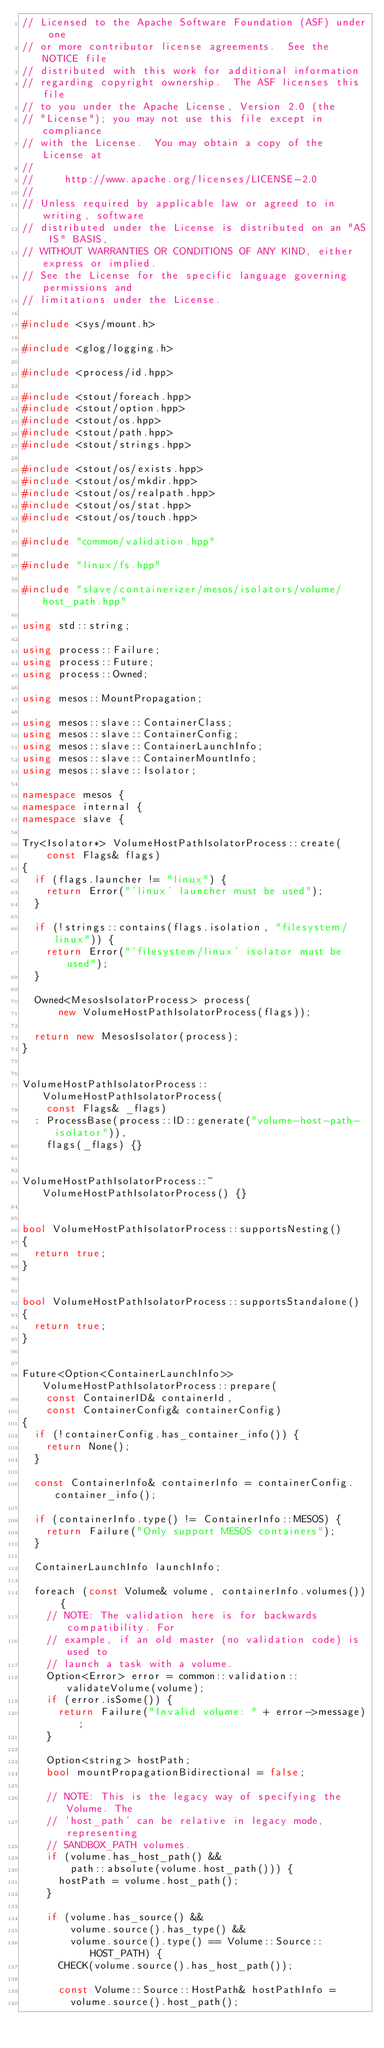<code> <loc_0><loc_0><loc_500><loc_500><_C++_>// Licensed to the Apache Software Foundation (ASF) under one
// or more contributor license agreements.  See the NOTICE file
// distributed with this work for additional information
// regarding copyright ownership.  The ASF licenses this file
// to you under the Apache License, Version 2.0 (the
// "License"); you may not use this file except in compliance
// with the License.  You may obtain a copy of the License at
//
//     http://www.apache.org/licenses/LICENSE-2.0
//
// Unless required by applicable law or agreed to in writing, software
// distributed under the License is distributed on an "AS IS" BASIS,
// WITHOUT WARRANTIES OR CONDITIONS OF ANY KIND, either express or implied.
// See the License for the specific language governing permissions and
// limitations under the License.

#include <sys/mount.h>

#include <glog/logging.h>

#include <process/id.hpp>

#include <stout/foreach.hpp>
#include <stout/option.hpp>
#include <stout/os.hpp>
#include <stout/path.hpp>
#include <stout/strings.hpp>

#include <stout/os/exists.hpp>
#include <stout/os/mkdir.hpp>
#include <stout/os/realpath.hpp>
#include <stout/os/stat.hpp>
#include <stout/os/touch.hpp>

#include "common/validation.hpp"

#include "linux/fs.hpp"

#include "slave/containerizer/mesos/isolators/volume/host_path.hpp"

using std::string;

using process::Failure;
using process::Future;
using process::Owned;

using mesos::MountPropagation;

using mesos::slave::ContainerClass;
using mesos::slave::ContainerConfig;
using mesos::slave::ContainerLaunchInfo;
using mesos::slave::ContainerMountInfo;
using mesos::slave::Isolator;

namespace mesos {
namespace internal {
namespace slave {

Try<Isolator*> VolumeHostPathIsolatorProcess::create(
    const Flags& flags)
{
  if (flags.launcher != "linux") {
    return Error("'linux' launcher must be used");
  }

  if (!strings::contains(flags.isolation, "filesystem/linux")) {
    return Error("'filesystem/linux' isolator must be used");
  }

  Owned<MesosIsolatorProcess> process(
      new VolumeHostPathIsolatorProcess(flags));

  return new MesosIsolator(process);
}


VolumeHostPathIsolatorProcess::VolumeHostPathIsolatorProcess(
    const Flags& _flags)
  : ProcessBase(process::ID::generate("volume-host-path-isolator")),
    flags(_flags) {}


VolumeHostPathIsolatorProcess::~VolumeHostPathIsolatorProcess() {}


bool VolumeHostPathIsolatorProcess::supportsNesting()
{
  return true;
}


bool VolumeHostPathIsolatorProcess::supportsStandalone()
{
  return true;
}


Future<Option<ContainerLaunchInfo>> VolumeHostPathIsolatorProcess::prepare(
    const ContainerID& containerId,
    const ContainerConfig& containerConfig)
{
  if (!containerConfig.has_container_info()) {
    return None();
  }

  const ContainerInfo& containerInfo = containerConfig.container_info();

  if (containerInfo.type() != ContainerInfo::MESOS) {
    return Failure("Only support MESOS containers");
  }

  ContainerLaunchInfo launchInfo;

  foreach (const Volume& volume, containerInfo.volumes()) {
    // NOTE: The validation here is for backwards compatibility. For
    // example, if an old master (no validation code) is used to
    // launch a task with a volume.
    Option<Error> error = common::validation::validateVolume(volume);
    if (error.isSome()) {
      return Failure("Invalid volume: " + error->message);
    }

    Option<string> hostPath;
    bool mountPropagationBidirectional = false;

    // NOTE: This is the legacy way of specifying the Volume. The
    // 'host_path' can be relative in legacy mode, representing
    // SANDBOX_PATH volumes.
    if (volume.has_host_path() &&
        path::absolute(volume.host_path())) {
      hostPath = volume.host_path();
    }

    if (volume.has_source() &&
        volume.source().has_type() &&
        volume.source().type() == Volume::Source::HOST_PATH) {
      CHECK(volume.source().has_host_path());

      const Volume::Source::HostPath& hostPathInfo =
        volume.source().host_path();
</code> 